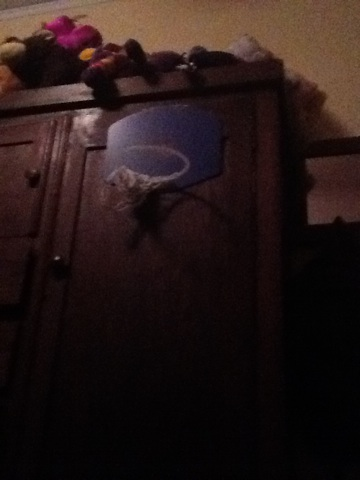Imagine if the stuffed animals in the room could talk. What conversation might they have? If the stuffed animals in the room could talk, they might have a lively and supportive conversation about Jamie's basketball skills. They could strategize about the best ways to help Jamie improve their shots, share stories about their adventures while Jamie is away, and possibly even argue playfully about who gets to be the MVP of their imaginary basketball team. Describe what this room might look like during a holiday season. During the holiday season, this room might be adorned with festive decorations. There could be string lights hanging around the wardrobe, illuminating the basketball hoop with a warm, festive glow. The stuffed animals might be wearing tiny holiday hats or scarves, adding to the cheerful ambiance. A small, decorated tree could be placed in a corner of the room, and maybe some holiday-themed posters or art would be on the walls. The entire space would feel cozy and filled with holiday spirit, perfect for relaxing and enjoying the festive season. 